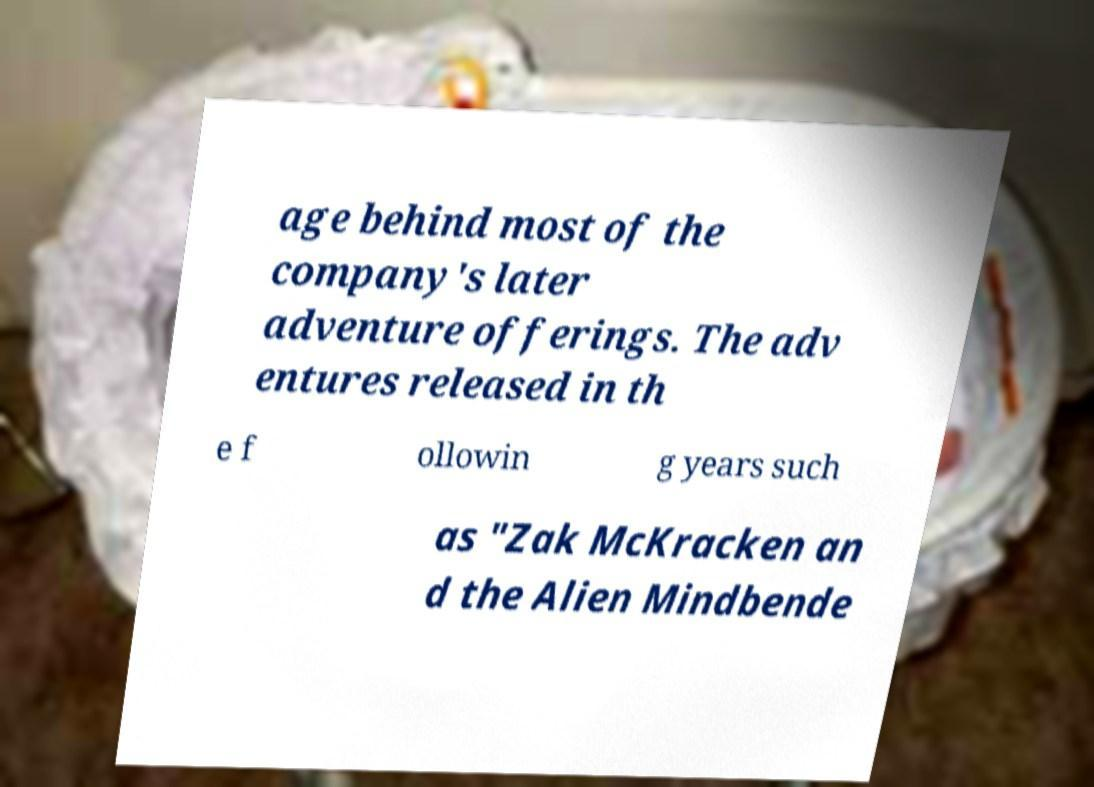Can you read and provide the text displayed in the image?This photo seems to have some interesting text. Can you extract and type it out for me? age behind most of the company's later adventure offerings. The adv entures released in th e f ollowin g years such as "Zak McKracken an d the Alien Mindbende 